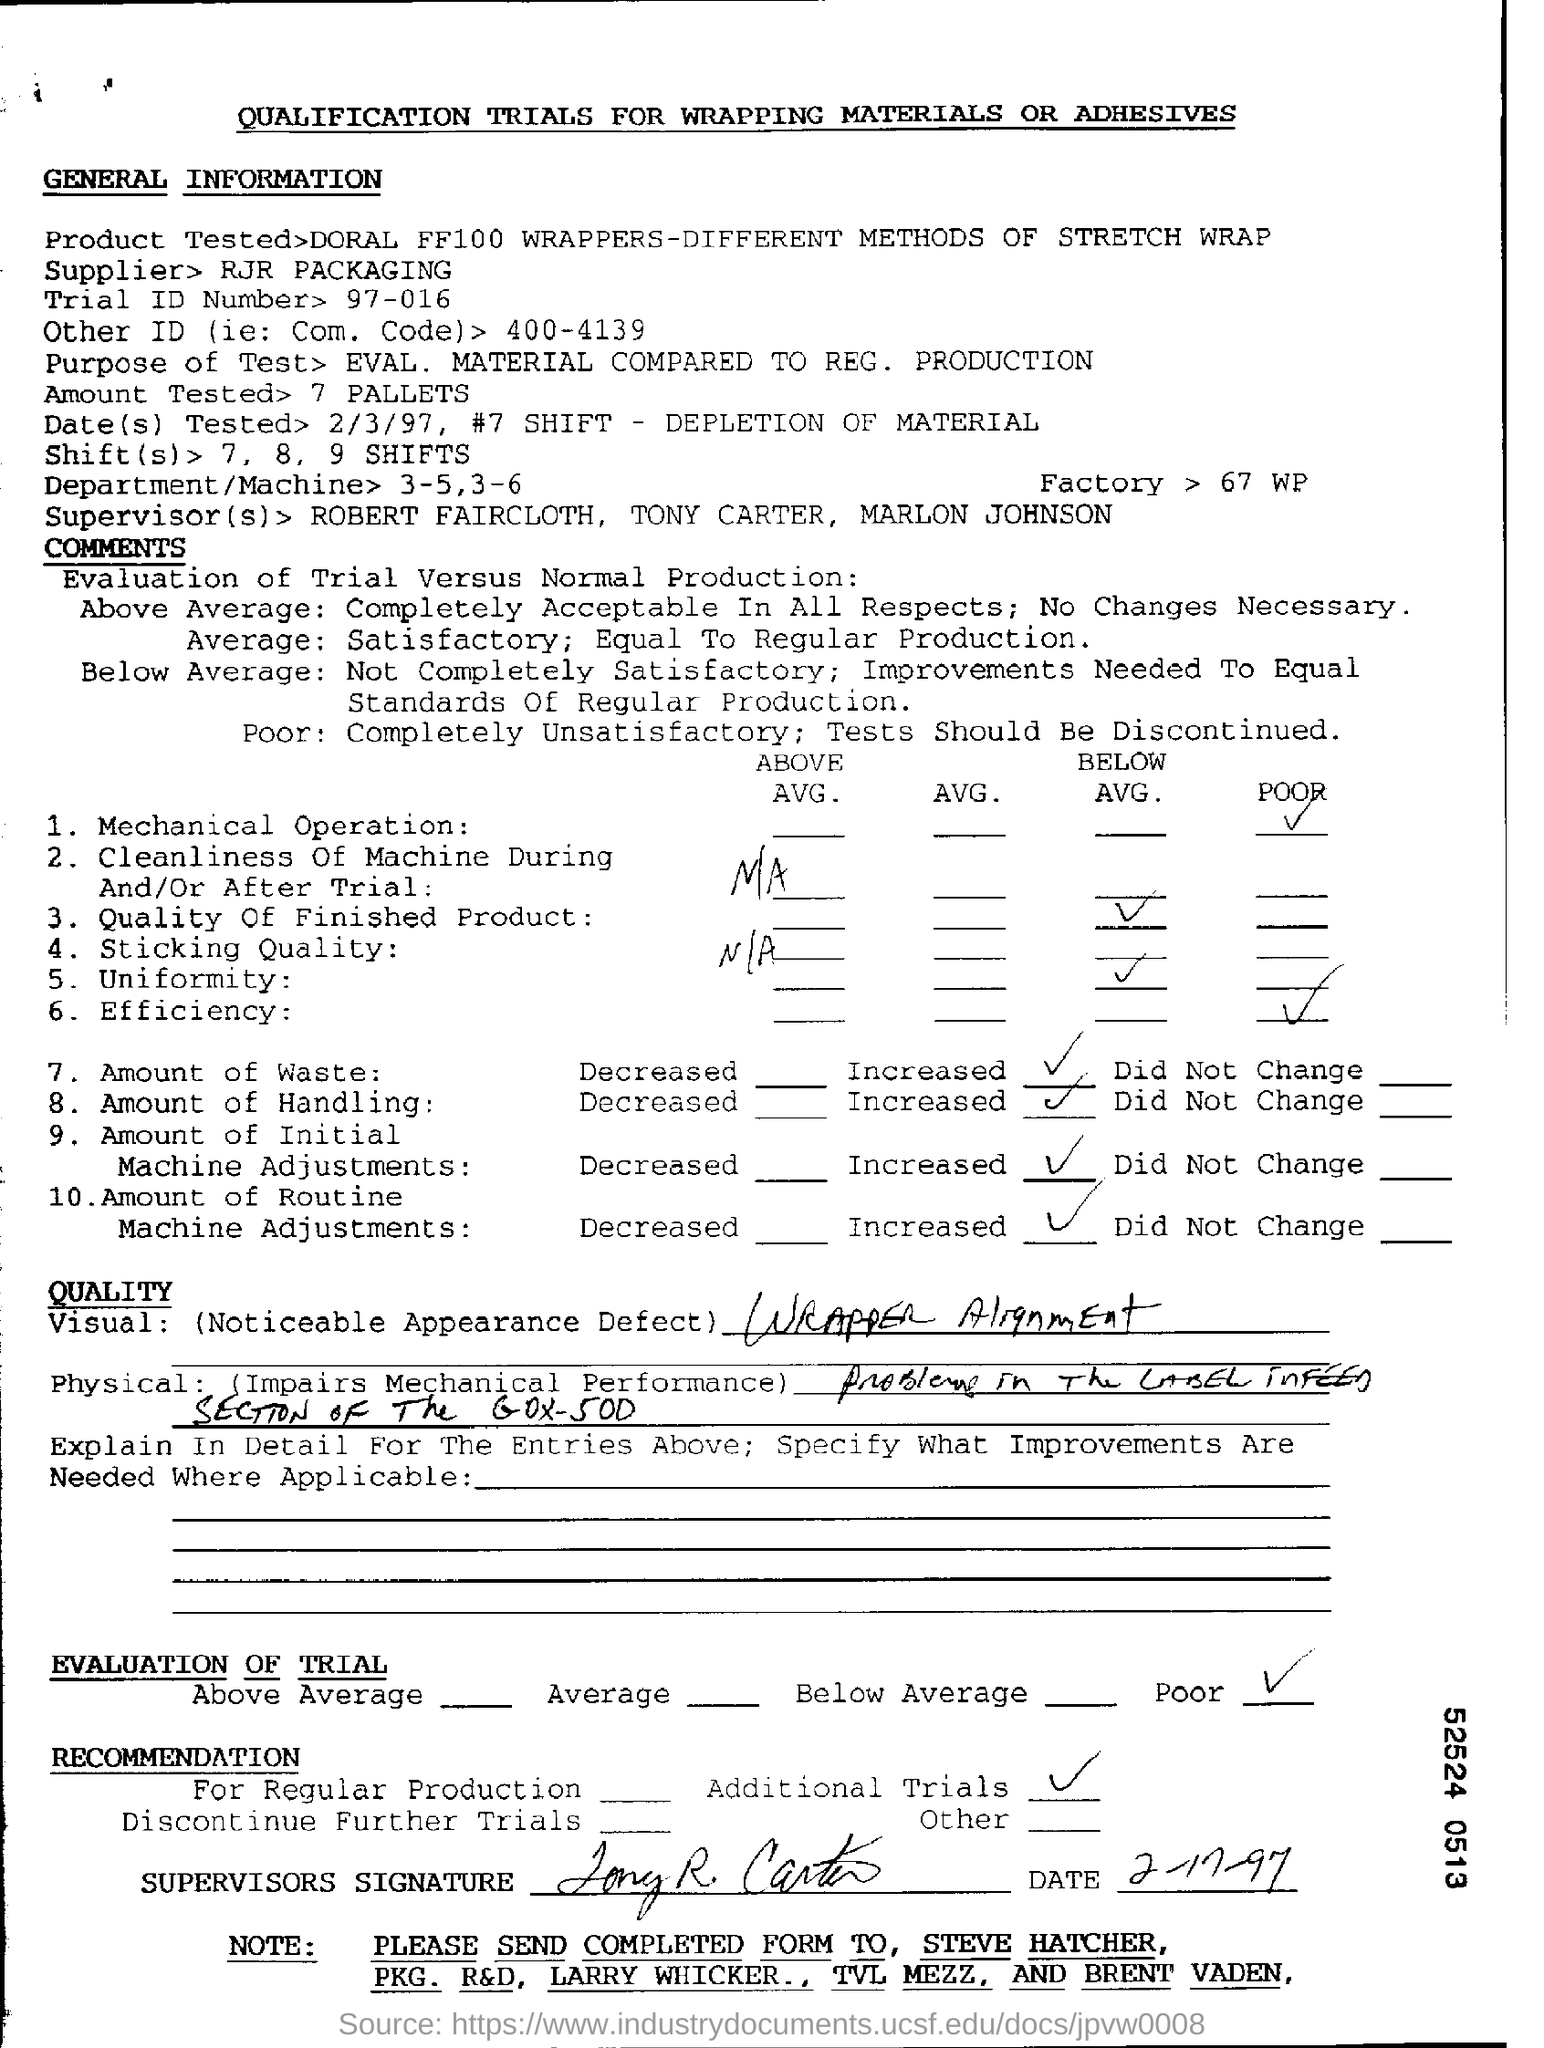List a handful of essential elements in this visual. The mechanical operation is poor. The page title is "QUALIFICATION TRIALS FOR WRAPPING MATERIALS OR ADHESIVES: The trial ID number is 97-016... RJR Packaging is the supplier. The recommended treatment plan for the patient is based on the evaluation results, and additional trials may be necessary. 